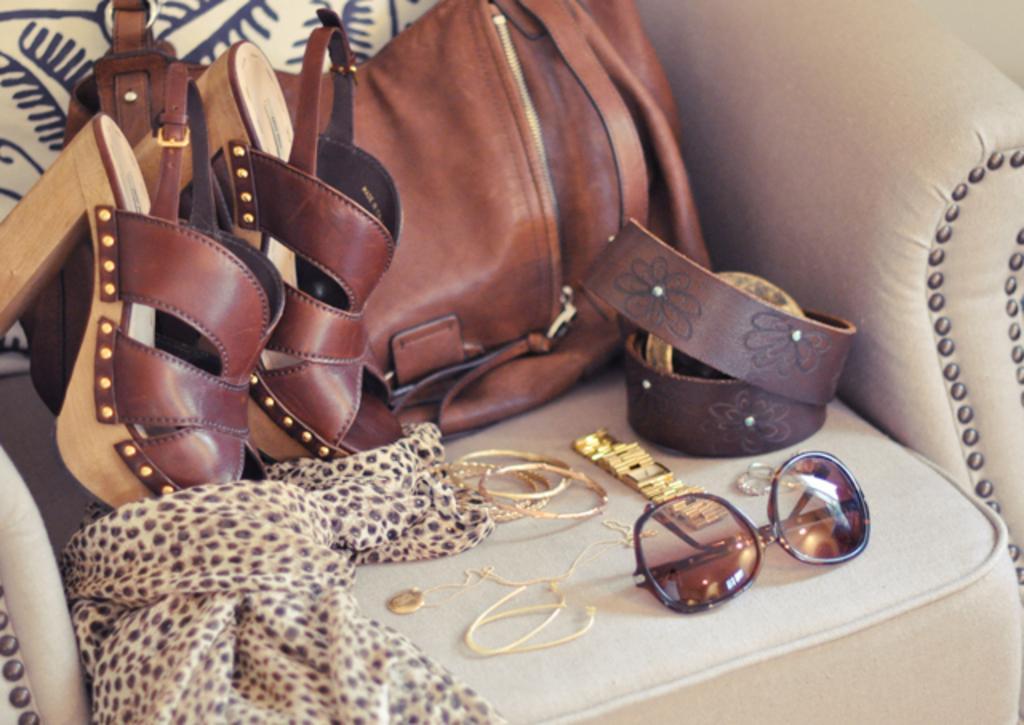Could you give a brief overview of what you see in this image? In this picture on a chair there are the sandals, bag, belt, goggle, bangle, watch, chain and a scarf. 